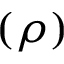<formula> <loc_0><loc_0><loc_500><loc_500>( \rho )</formula> 